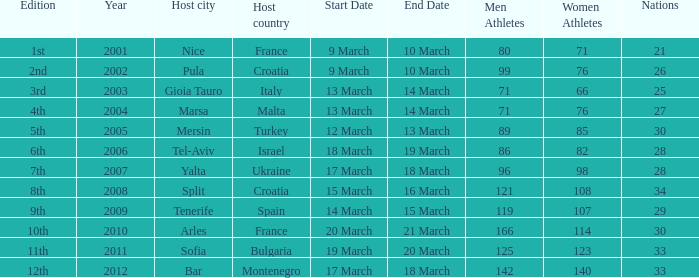I'm looking to parse the entire table for insights. Could you assist me with that? {'header': ['Edition', 'Year', 'Host city', 'Host country', 'Start Date', 'End Date', 'Men Athletes', 'Women Athletes', 'Nations'], 'rows': [['1st', '2001', 'Nice', 'France', '9 March', '10 March', '80', '71', '21'], ['2nd', '2002', 'Pula', 'Croatia', '9 March', '10 March', '99', '76', '26'], ['3rd', '2003', 'Gioia Tauro', 'Italy', '13 March', '14 March', '71', '66', '25'], ['4th', '2004', 'Marsa', 'Malta', '13 March', '14 March', '71', '76', '27'], ['5th', '2005', 'Mersin', 'Turkey', '12 March', '13 March', '89', '85', '30'], ['6th', '2006', 'Tel-Aviv', 'Israel', '18 March', '19 March', '86', '82', '28'], ['7th', '2007', 'Yalta', 'Ukraine', '17 March', '18 March', '96', '98', '28'], ['8th', '2008', 'Split', 'Croatia', '15 March', '16 March', '121', '108', '34'], ['9th', '2009', 'Tenerife', 'Spain', '14 March', '15 March', '119', '107', '29'], ['10th', '2010', 'Arles', 'France', '20 March', '21 March', '166', '114', '30'], ['11th', '2011', 'Sofia', 'Bulgaria', '19 March', '20 March', '125', '123', '33'], ['12th', '2012', 'Bar', 'Montenegro', '17 March', '18 March', '142', '140', '33']]} What was the most recent year? 2012.0. 